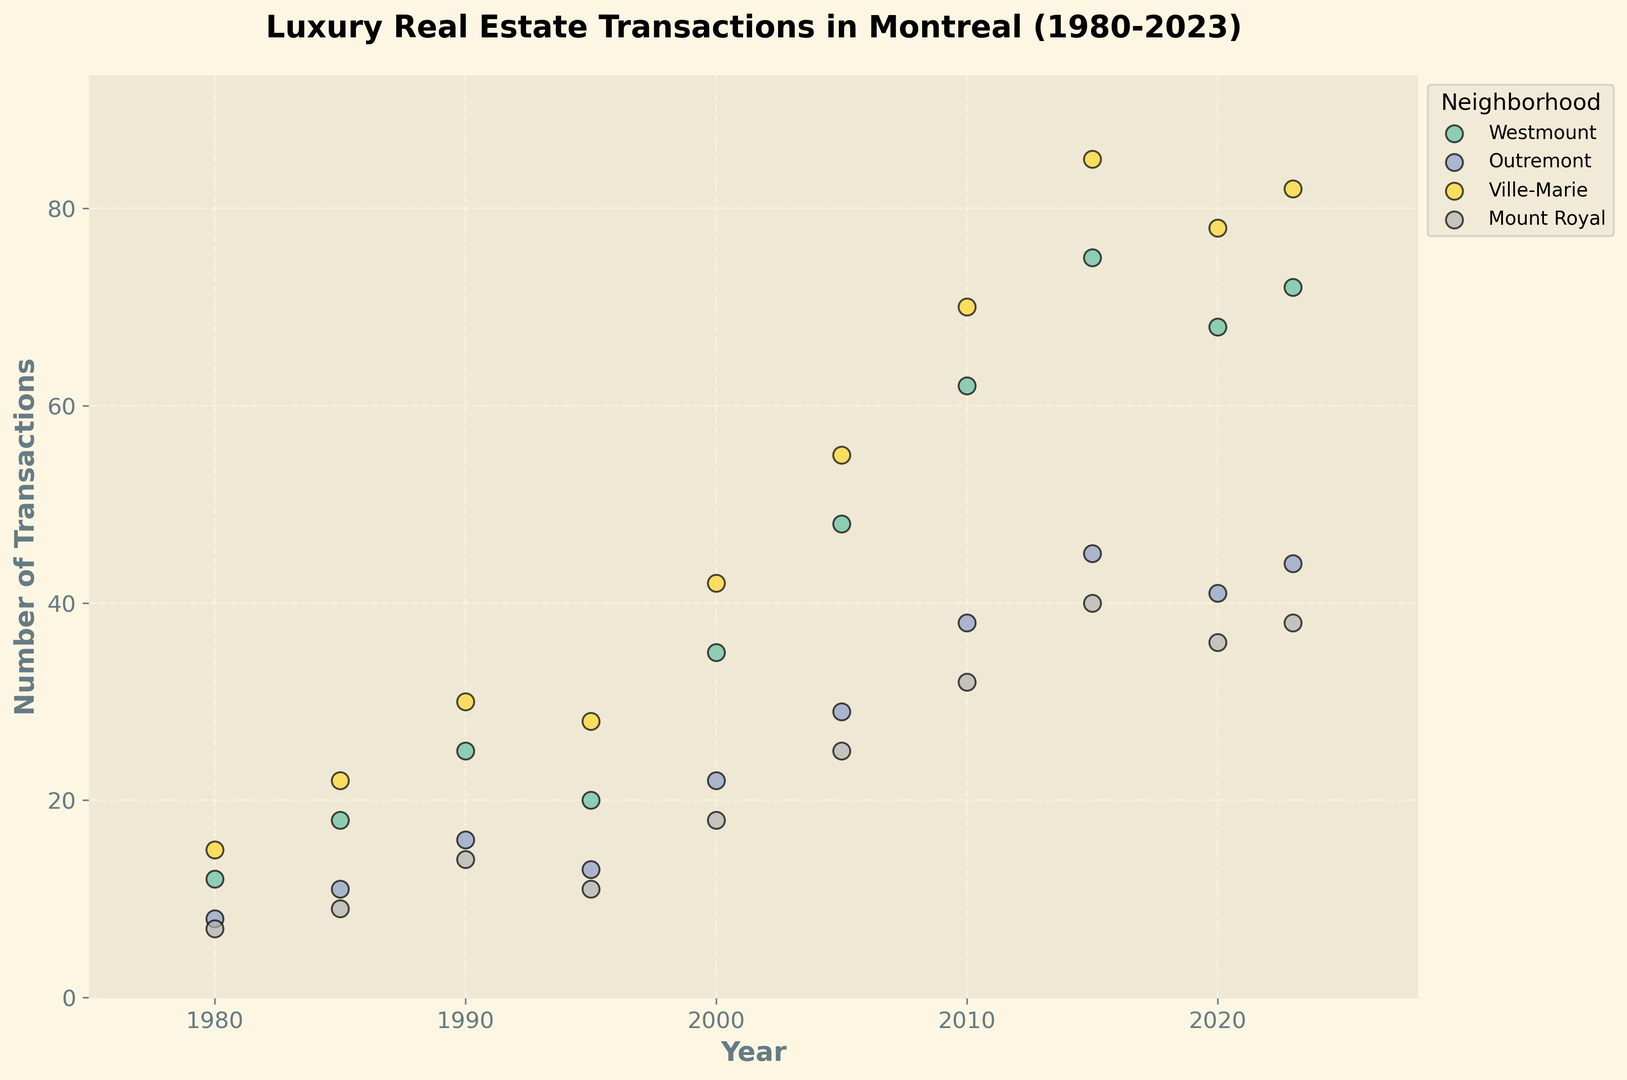What neighborhood had the highest number of transactions in 2023? The point for Ville-Marie in 2023 is the highest relative to other neighborhoods in that year with 82 transactions.
Answer: Ville-Marie Comparing 1985 and 1990, which neighborhood saw the highest absolute increase in transactions? Ville-Marie increased from 22 transactions in 1985 to 30 in 1990, an increase of 8, which is the highest among all neighborhoods.
Answer: Ville-Marie What is the trend in the number of transactions for Westmount from 1980 to 2023? The scatter points for Westmount generally increase from 12 in 1980 to a peak in 2015 with 75 transactions, then slightly decrease to 72 in 2023.
Answer: Increasing, then slight decrease Which neighborhood shows the least fluctuation in transaction numbers from 2000 to 2023? Mount Royal’s transaction numbers show relatively less fluctuation, with points around 18 (2000), 25 (2005), 32 (2010), 40 (2015), 36 (2020), and 38 (2023).
Answer: Mount Royal Did any neighborhood have exactly the same number of transactions in two separate years? Outremont had 44 transactions in both 2015 and 2023.
Answer: Outremont What's the average number of transactions for Outremont in the years 2010, 2015, and 2020? Summing up the number of transactions for Outremont (38 in 2010, 45 in 2015, and 41 in 2020) gives 124. The average is 124/3 = 41.33.
Answer: 41.33 In which year did Ville-Marie see the largest single-year increase in transactions? From 2005 to 2010, Ville-Marie increased from 55 to 70 transactions, which is a 15 transaction increase, the largest single-year increase.
Answer: 2010 Visualizing the highest transaction points in the plot, which neighborhood appears the most frequently? Ville-Marie has the highest points in most years: 1980, 1985, 1990, 2000, 2005, 2010, and 2015.
Answer: Ville-Marie Which neighborhood had the smallest number of transactions in 1995? Mount Royal, with 11 transactions, shows the lowest point in 1995 compared to other neighborhoods in that year.
Answer: Mount Royal What’s the overall trend for transactions in Ville-Marie from 1980 to 2023? The trend for Ville-Marie is generally increasing, starting at 15 in 1980 and reaching 82 in 2023, with occasional fluctuations.
Answer: Increasing 